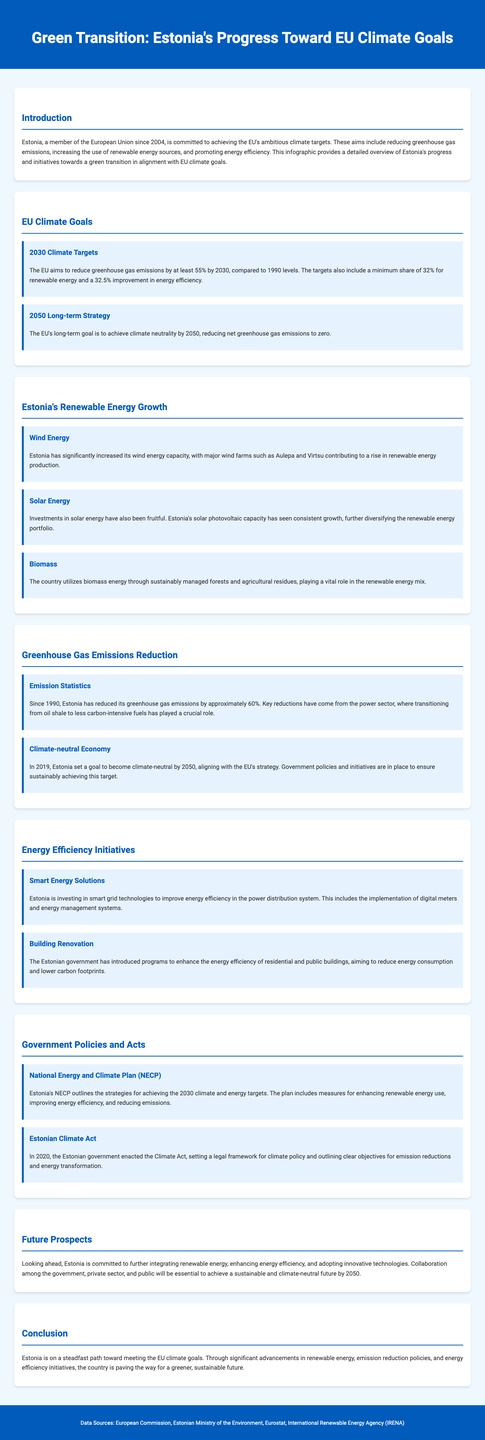what year did Estonia join the EU? The document mentions that Estonia became a member of the European Union in 2004.
Answer: 2004 what is the EU's target for renewable energy by 2030? The infographic states that the EU aims for a minimum share of 32% for renewable energy by 2030.
Answer: 32% by what percentage has Estonia reduced its greenhouse gas emissions since 1990? According to the document, Estonia has reduced its greenhouse gas emissions by approximately 60% since 1990.
Answer: 60% what is one major source of renewable energy growth in Estonia? The document highlights wind energy, noting the contribution of major wind farms.
Answer: Wind energy what goal did Estonia set for becoming climate-neutral? The infographic states that Estonia set a goal to become climate-neutral by 2050.
Answer: 2050 which act outlines Estonia's climate policy framework? The Estonian Climate Act, enacted in 2020, provides a legal framework for climate policy.
Answer: Estonian Climate Act what is the key focus of the National Energy and Climate Plan (NECP)? The NECP outlines strategies for achieving the 2030 climate and energy targets in Estonia.
Answer: Achieving 2030 targets how does Estonia plan to improve energy efficiency in buildings? The document mentions that programs are in place to enhance energy efficiency in residential and public buildings.
Answer: Renovation programs what is the long-term climate goal of the EU for 2050? The EU's long-term goal is to achieve climate neutrality by 2050, according to the document.
Answer: Climate neutrality 